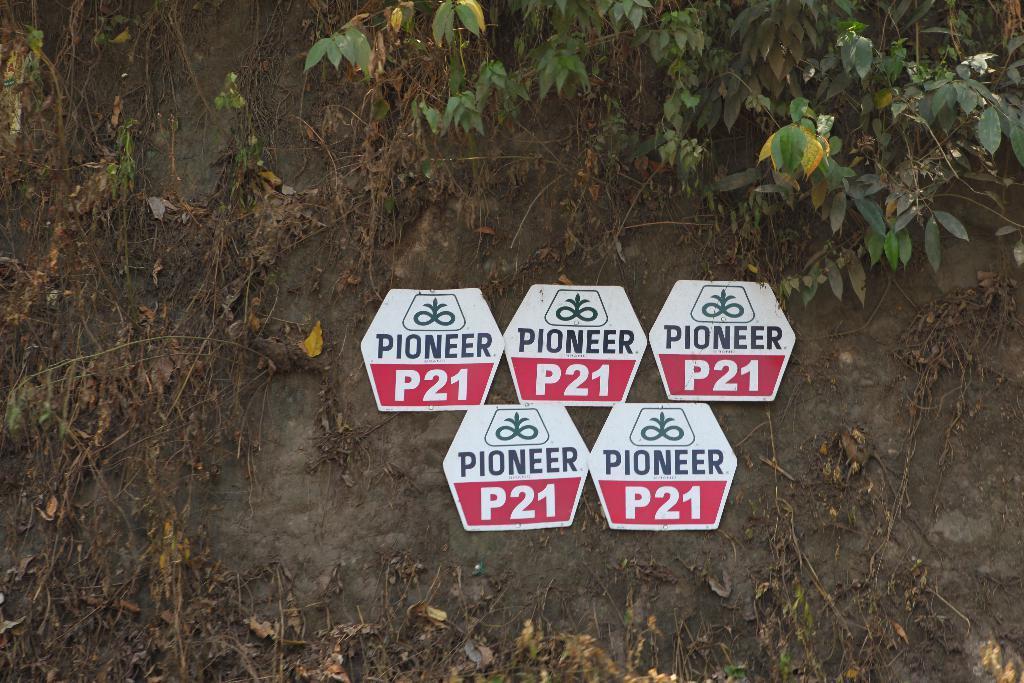Describe this image in one or two sentences. In this image, we can see few boards, plants and dry leaves with stems. 